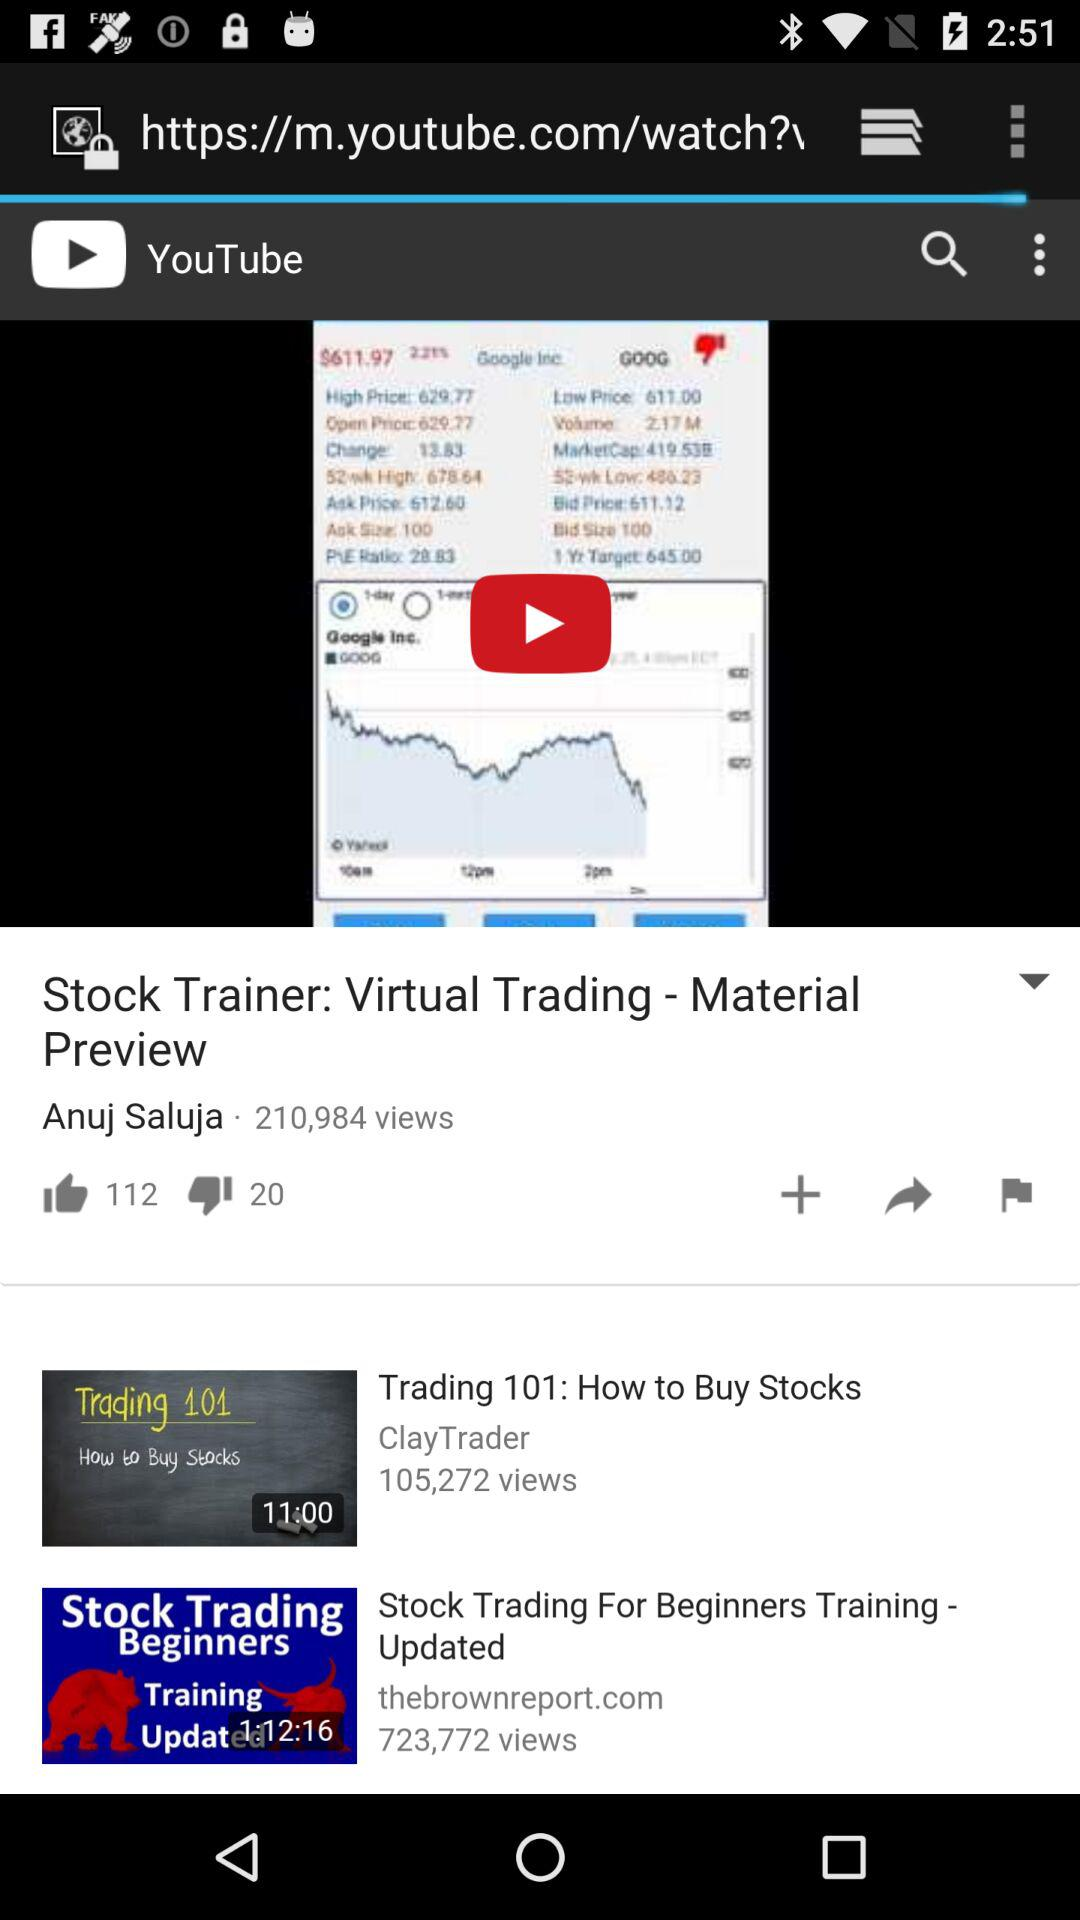How many people have not liked the video?
Answer the question using a single word or phrase. 20 people have not liked the video 